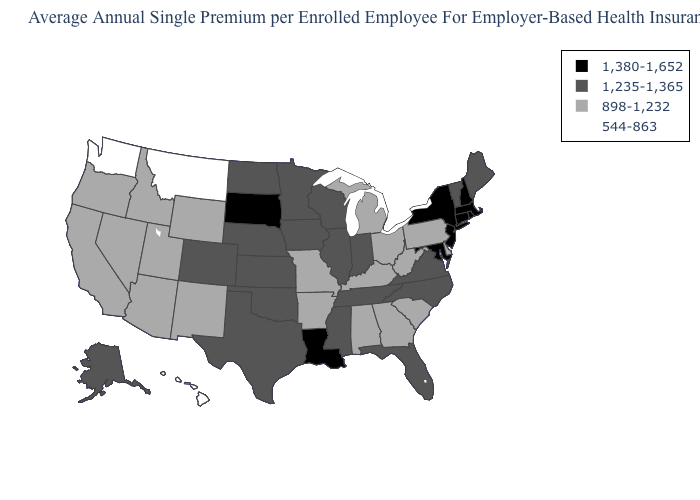Name the states that have a value in the range 1,235-1,365?
Write a very short answer. Alaska, Colorado, Florida, Illinois, Indiana, Iowa, Kansas, Maine, Minnesota, Mississippi, Nebraska, North Carolina, North Dakota, Oklahoma, Tennessee, Texas, Vermont, Virginia, Wisconsin. Name the states that have a value in the range 544-863?
Quick response, please. Hawaii, Montana, Washington. What is the value of Michigan?
Short answer required. 898-1,232. Name the states that have a value in the range 1,380-1,652?
Write a very short answer. Connecticut, Louisiana, Maryland, Massachusetts, New Hampshire, New Jersey, New York, Rhode Island, South Dakota. Name the states that have a value in the range 544-863?
Write a very short answer. Hawaii, Montana, Washington. Among the states that border Texas , does Arkansas have the highest value?
Answer briefly. No. What is the highest value in states that border North Dakota?
Give a very brief answer. 1,380-1,652. Among the states that border Alabama , does Mississippi have the lowest value?
Quick response, please. No. What is the lowest value in states that border New Mexico?
Give a very brief answer. 898-1,232. Does Louisiana have a lower value than Vermont?
Short answer required. No. Does Oklahoma have the lowest value in the South?
Be succinct. No. Does Minnesota have the highest value in the USA?
Short answer required. No. Which states have the lowest value in the USA?
Give a very brief answer. Hawaii, Montana, Washington. Does the map have missing data?
Be succinct. No. Name the states that have a value in the range 898-1,232?
Quick response, please. Alabama, Arizona, Arkansas, California, Delaware, Georgia, Idaho, Kentucky, Michigan, Missouri, Nevada, New Mexico, Ohio, Oregon, Pennsylvania, South Carolina, Utah, West Virginia, Wyoming. 